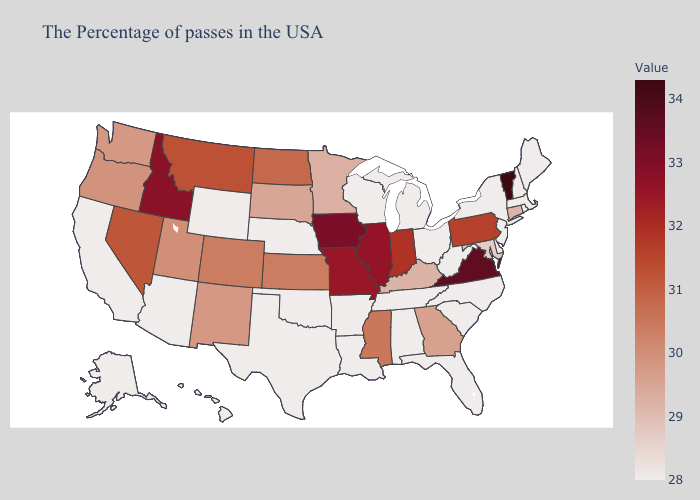Which states have the lowest value in the West?
Keep it brief. Wyoming, Arizona, California, Alaska, Hawaii. Does Iowa have the highest value in the MidWest?
Quick response, please. Yes. Among the states that border Louisiana , which have the highest value?
Answer briefly. Mississippi. 